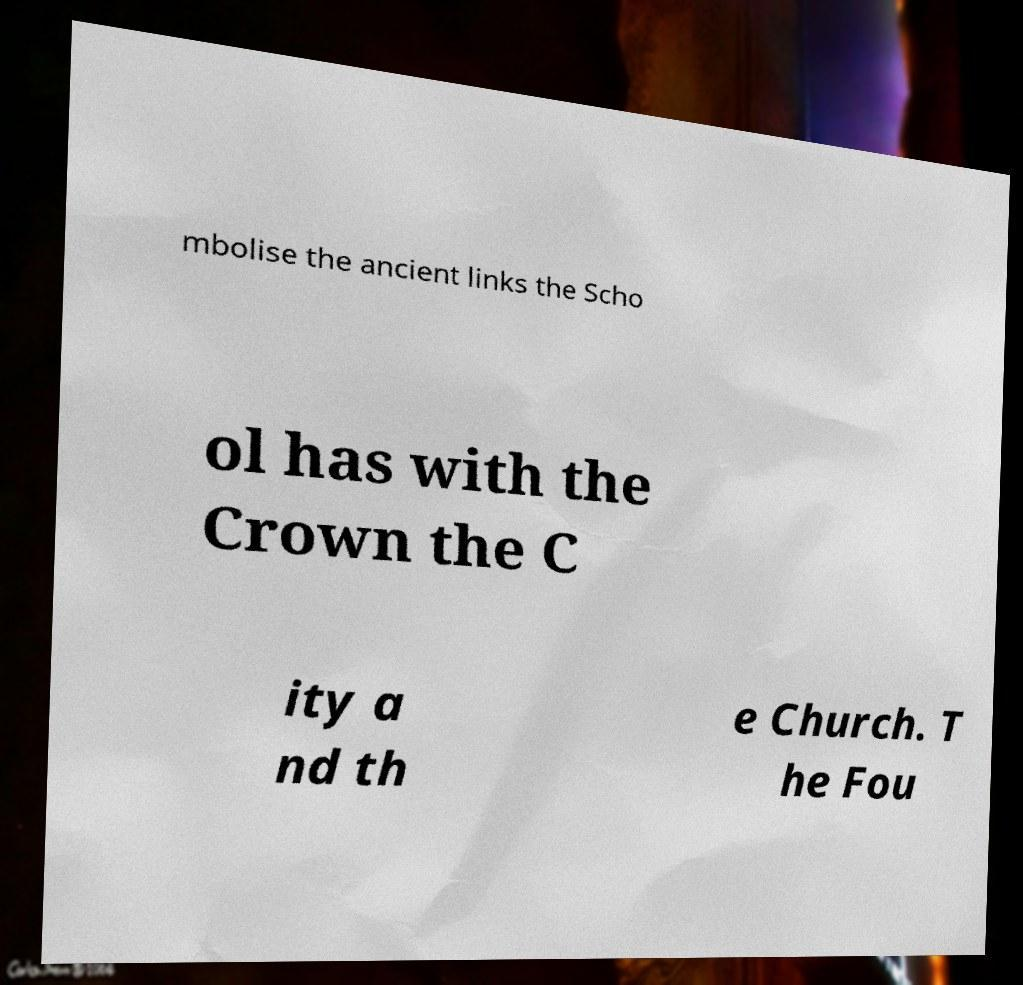Could you assist in decoding the text presented in this image and type it out clearly? mbolise the ancient links the Scho ol has with the Crown the C ity a nd th e Church. T he Fou 